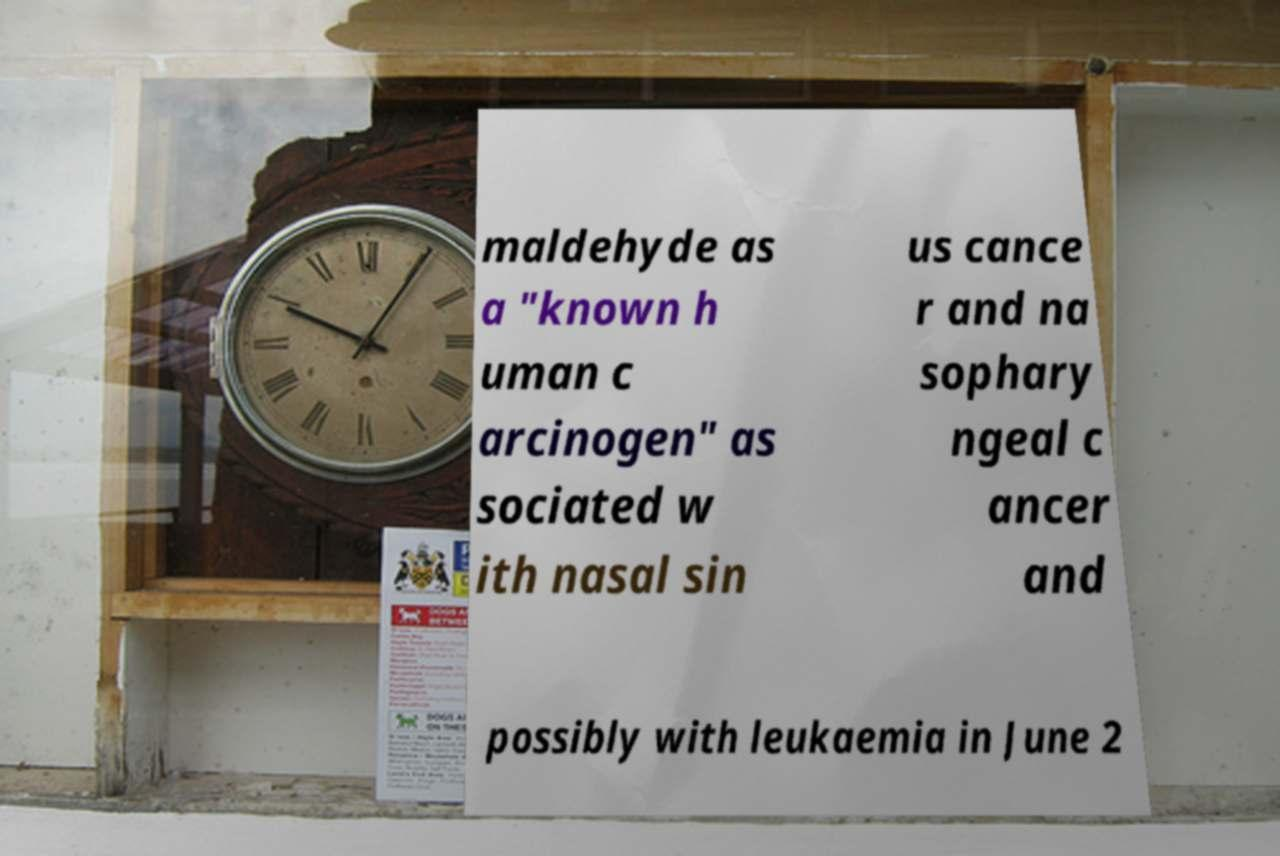I need the written content from this picture converted into text. Can you do that? maldehyde as a "known h uman c arcinogen" as sociated w ith nasal sin us cance r and na sophary ngeal c ancer and possibly with leukaemia in June 2 